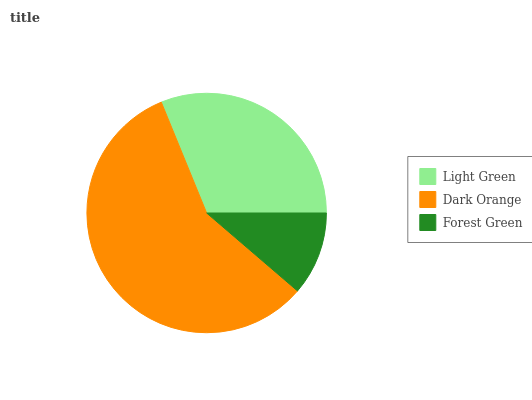Is Forest Green the minimum?
Answer yes or no. Yes. Is Dark Orange the maximum?
Answer yes or no. Yes. Is Dark Orange the minimum?
Answer yes or no. No. Is Forest Green the maximum?
Answer yes or no. No. Is Dark Orange greater than Forest Green?
Answer yes or no. Yes. Is Forest Green less than Dark Orange?
Answer yes or no. Yes. Is Forest Green greater than Dark Orange?
Answer yes or no. No. Is Dark Orange less than Forest Green?
Answer yes or no. No. Is Light Green the high median?
Answer yes or no. Yes. Is Light Green the low median?
Answer yes or no. Yes. Is Dark Orange the high median?
Answer yes or no. No. Is Dark Orange the low median?
Answer yes or no. No. 